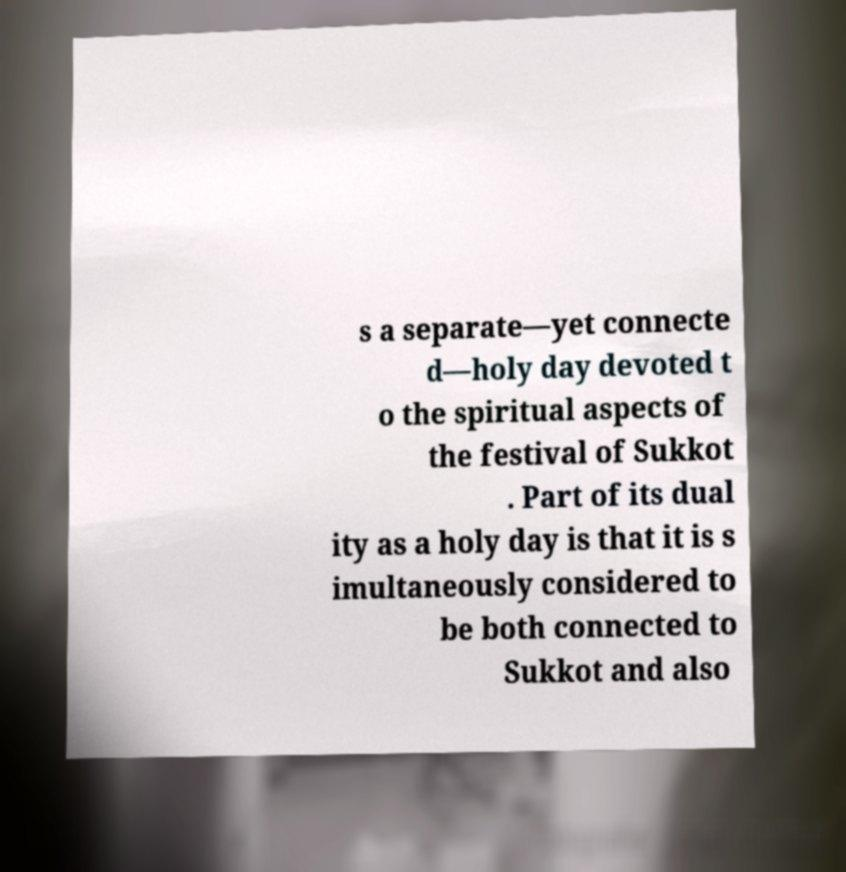For documentation purposes, I need the text within this image transcribed. Could you provide that? s a separate—yet connecte d—holy day devoted t o the spiritual aspects of the festival of Sukkot . Part of its dual ity as a holy day is that it is s imultaneously considered to be both connected to Sukkot and also 